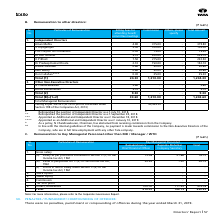According to Tata Consultancy Services's financial document, What is the total remuneration for Ramakrishnan V? According to the financial document, 413.07. The relevant text states: "5. Others, Allowances 297.47 117.29 414.76 Total 413.07 140.15 553.22..." Also, What is the value of Stock Option given to the Company Secretary? According to the financial document, 0. The relevant text states: "d in Section 17(1) of the Income-tax Act, 1961 72.06 21.66 93.72..." Also, What is the value of Commission given to the Chief Financial Officer? According to the financial document, 0. The relevant text states: "d in Section 17(1) of the Income-tax Act, 1961 72.06 21.66 93.72..." Also, can you calculate: What is the difference in Others, Allowances between the CFO and Company Secretary? Based on the calculation: 297.47-117.29 , the result is 180.18. This is based on the information: "- - - as % of profit - - - 5. Others, Allowances 297.47 117.29 414.76 Total 413.07 140.15 553.22 as % of profit - - - 5. Others, Allowances 297.47 117.29 414.76 Total 413.07 140.15 553.22..." The key data points involved are: 117.29, 297.47. Additionally, Which key managerial personnel had the highest total remuneration? Ramakrishnan V Chief Financial Officer. The document states: "ticulars of Remuneration Key Managerial Personnel Ramakrishnan V Chief Financial Officer Rajendra Moholkar Company Secretary Total..." Also, can you calculate: What is the difference in total gross salary of the CFO and Company Secretary? Based on the calculation: 72.06+43.54-(21.66+1.2), the result is 92.74. This is based on the information: "isites u/s 17(2) of the Income-tax Act, 1961 43.54 1.20 44.74 n Section 17(1) of the Income-tax Act, 1961 72.06 21.66 93.72 perquisites u/s 17(2) of the Income-tax Act, 1961 43.54 1.20 44.74 ined in S..." The key data points involved are: 1.2, 21.66, 43.54. 